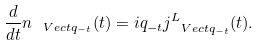Convert formula to latex. <formula><loc_0><loc_0><loc_500><loc_500>\frac { d } { d t } n _ { \ V e c t { q } _ { - t } } ( t ) = i q _ { - t } j _ { \ V e c t { q } _ { - t } } ^ { L } ( t ) .</formula> 